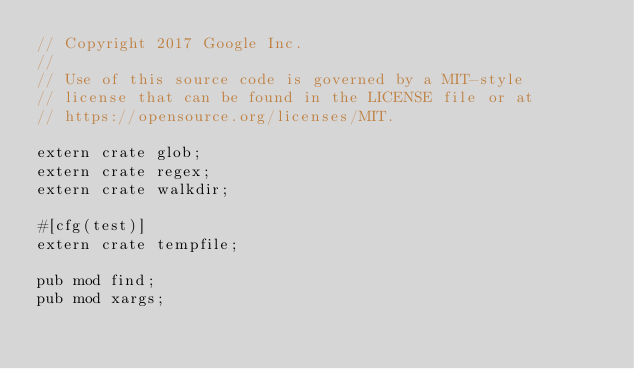<code> <loc_0><loc_0><loc_500><loc_500><_Rust_>// Copyright 2017 Google Inc.
//
// Use of this source code is governed by a MIT-style
// license that can be found in the LICENSE file or at
// https://opensource.org/licenses/MIT.

extern crate glob;
extern crate regex;
extern crate walkdir;

#[cfg(test)]
extern crate tempfile;

pub mod find;
pub mod xargs;
</code> 